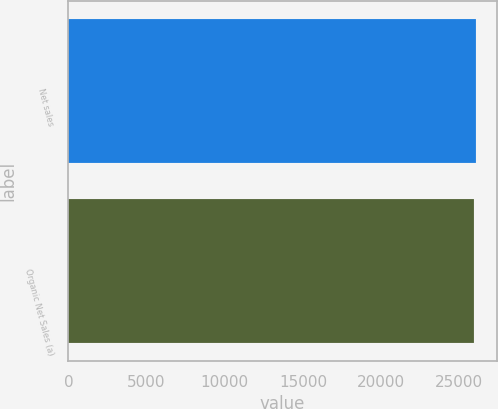<chart> <loc_0><loc_0><loc_500><loc_500><bar_chart><fcel>Net sales<fcel>Organic Net Sales (a)<nl><fcel>26076<fcel>25963<nl></chart> 